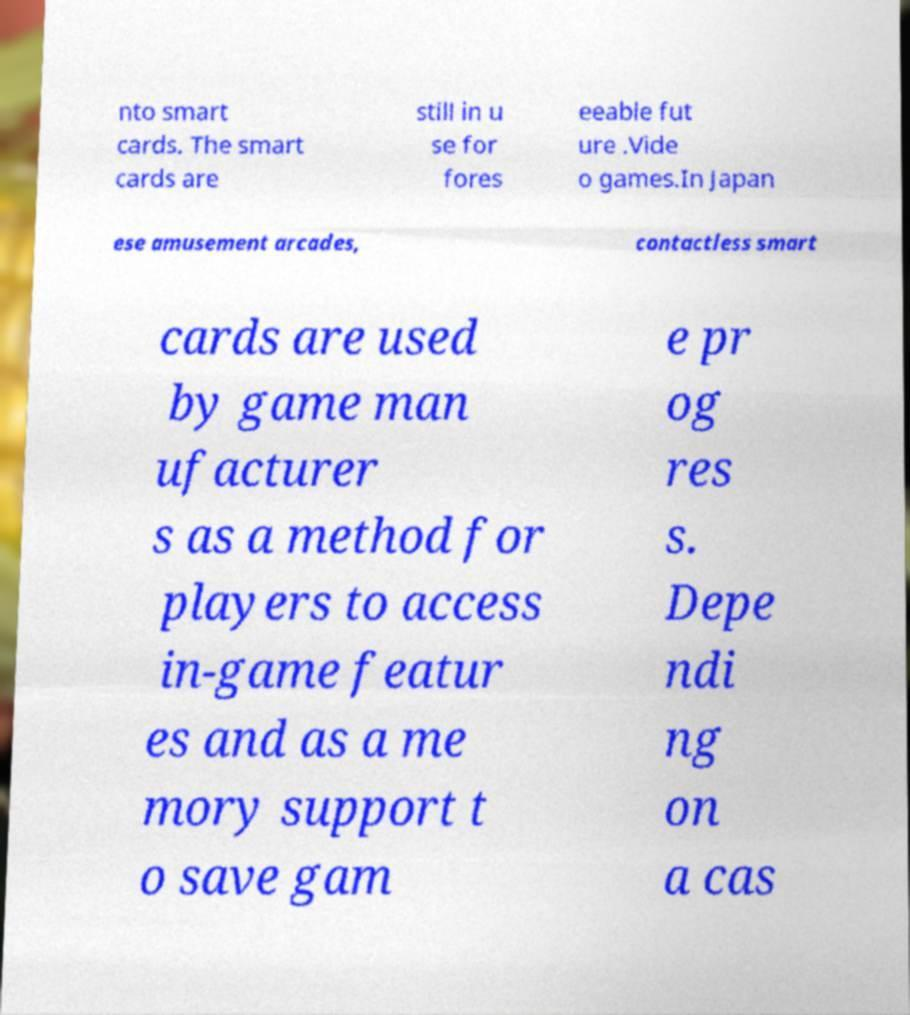Please read and relay the text visible in this image. What does it say? nto smart cards. The smart cards are still in u se for fores eeable fut ure .Vide o games.In Japan ese amusement arcades, contactless smart cards are used by game man ufacturer s as a method for players to access in-game featur es and as a me mory support t o save gam e pr og res s. Depe ndi ng on a cas 